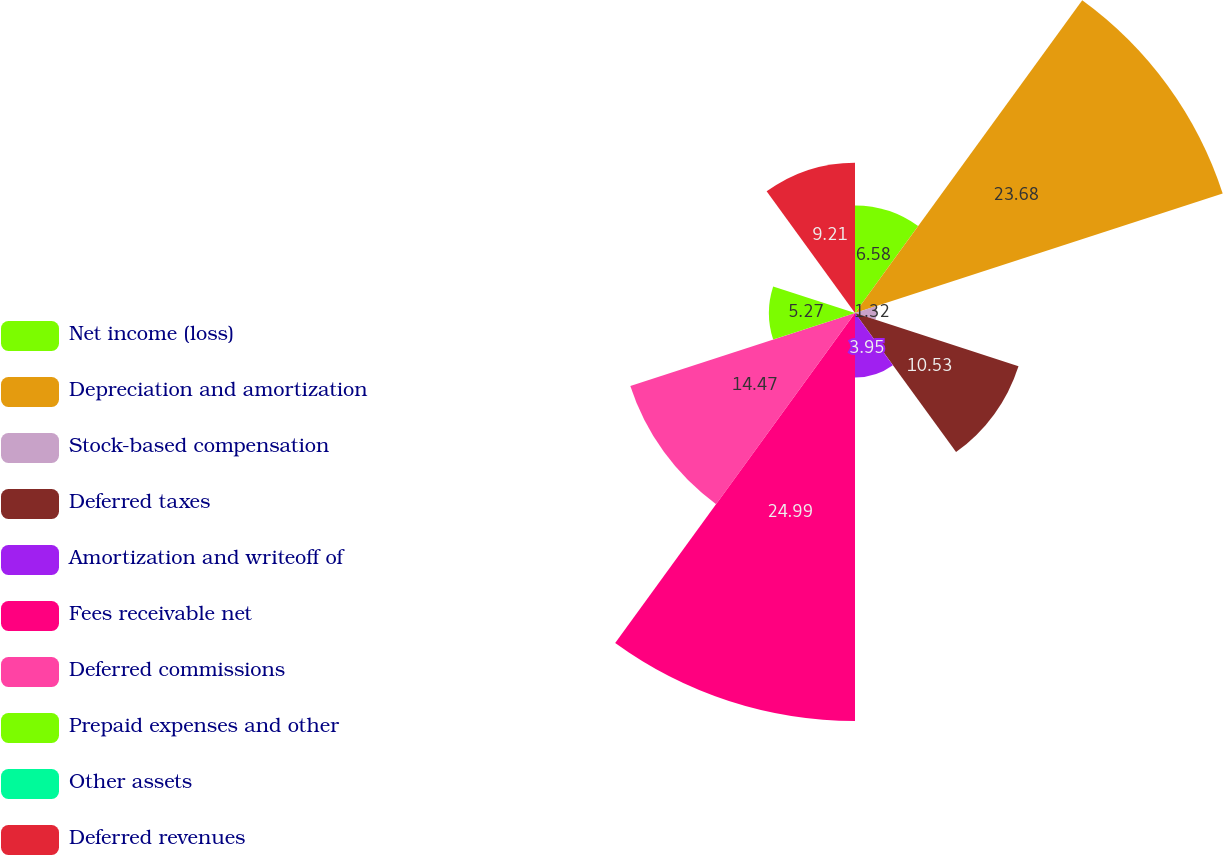Convert chart. <chart><loc_0><loc_0><loc_500><loc_500><pie_chart><fcel>Net income (loss)<fcel>Depreciation and amortization<fcel>Stock-based compensation<fcel>Deferred taxes<fcel>Amortization and writeoff of<fcel>Fees receivable net<fcel>Deferred commissions<fcel>Prepaid expenses and other<fcel>Other assets<fcel>Deferred revenues<nl><fcel>6.58%<fcel>23.68%<fcel>1.32%<fcel>10.53%<fcel>3.95%<fcel>24.99%<fcel>14.47%<fcel>5.27%<fcel>0.0%<fcel>9.21%<nl></chart> 